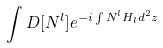Convert formula to latex. <formula><loc_0><loc_0><loc_500><loc_500>\int D [ N ^ { l } ] e ^ { - i \int N ^ { l } H _ { l } d ^ { 2 } z }</formula> 